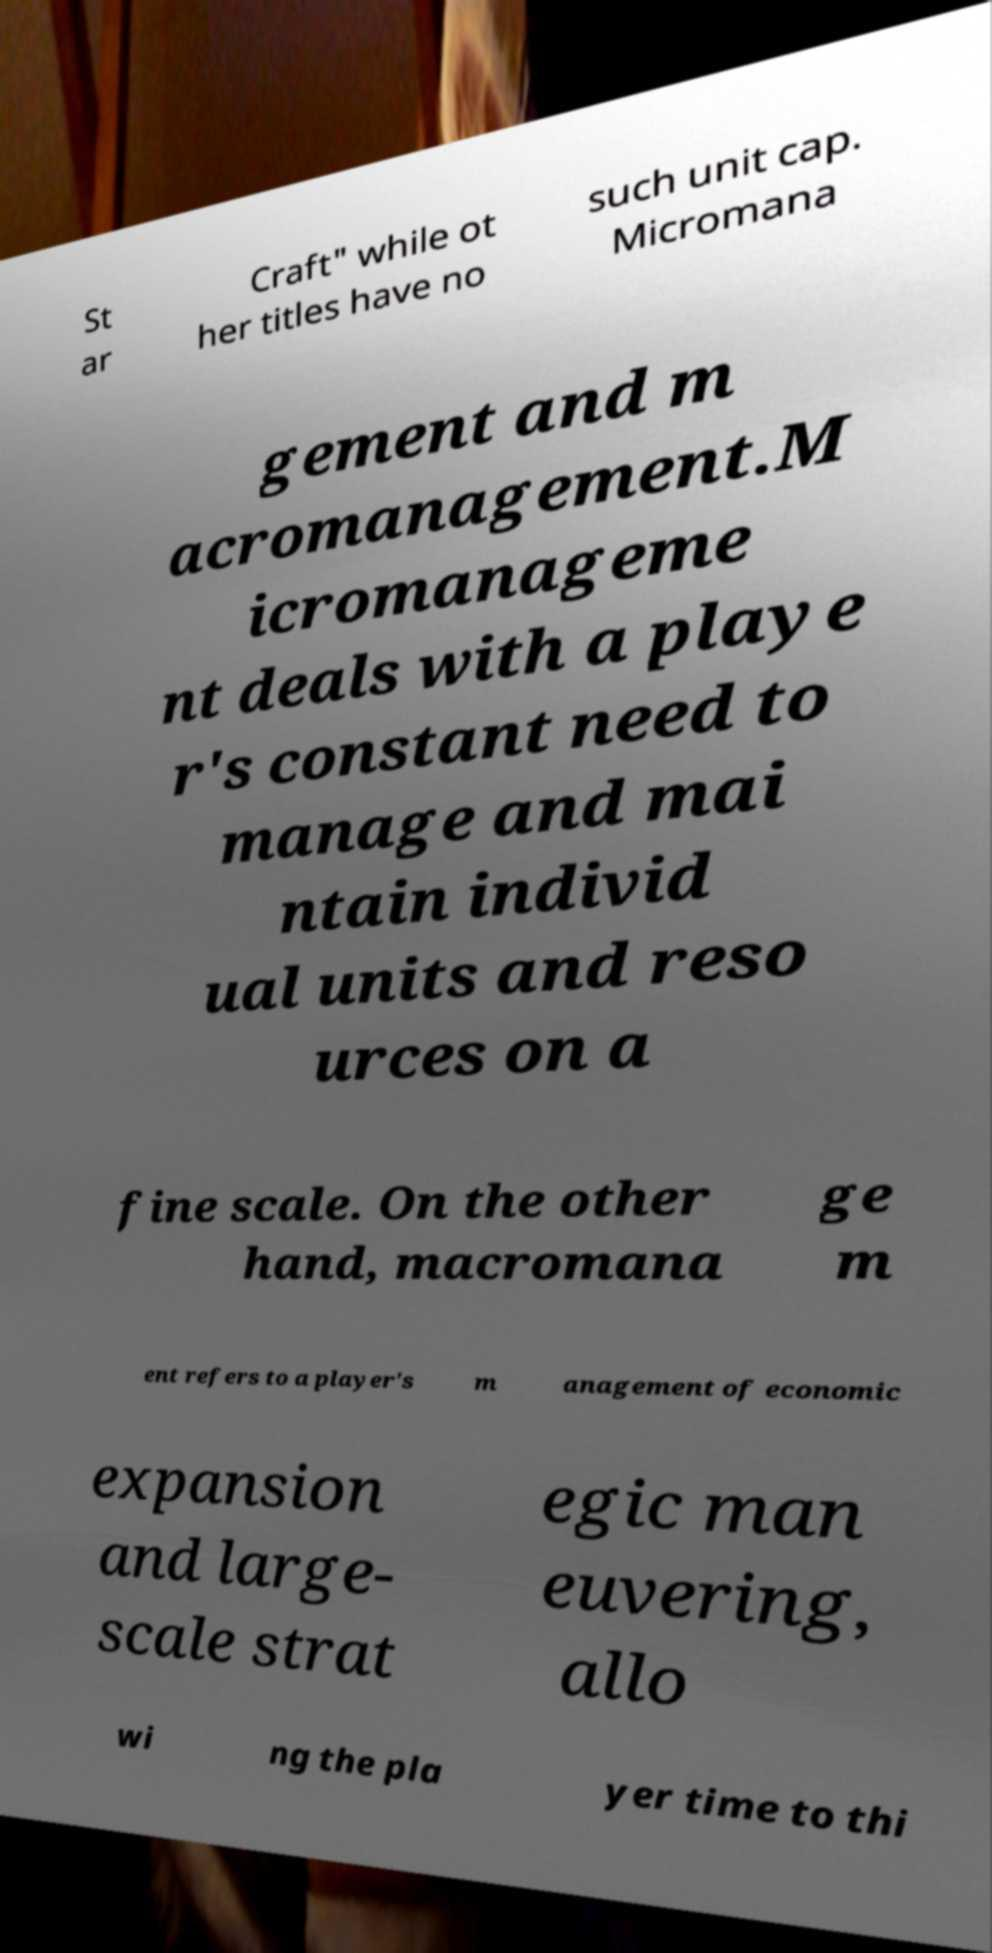There's text embedded in this image that I need extracted. Can you transcribe it verbatim? St ar Craft" while ot her titles have no such unit cap. Micromana gement and m acromanagement.M icromanageme nt deals with a playe r's constant need to manage and mai ntain individ ual units and reso urces on a fine scale. On the other hand, macromana ge m ent refers to a player's m anagement of economic expansion and large- scale strat egic man euvering, allo wi ng the pla yer time to thi 